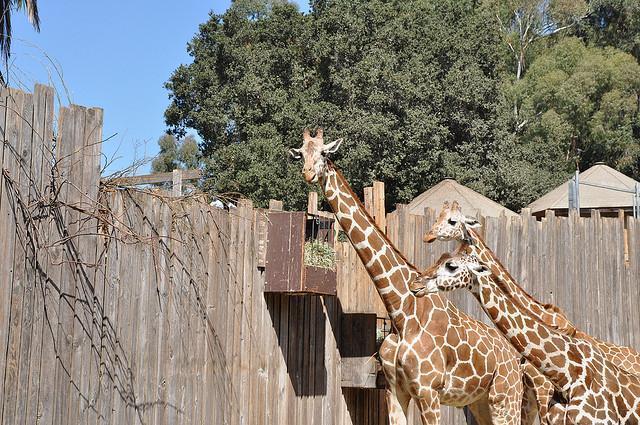How many giraffes are in the photo?
Give a very brief answer. 3. How many bottles of soap are by the sinks?
Give a very brief answer. 0. 